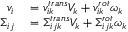Convert formula to latex. <formula><loc_0><loc_0><loc_500><loc_500>\begin{array} { r l } { v _ { i } } & = v _ { i k } ^ { t r a n s } V _ { k } + v _ { i k } ^ { r o t } \omega _ { k } } \\ { \Sigma _ { i j } } & = \Sigma _ { i j k } ^ { t r a n s } V _ { k } + \Sigma _ { i j k } ^ { r o t } \omega _ { k } } \end{array}</formula> 